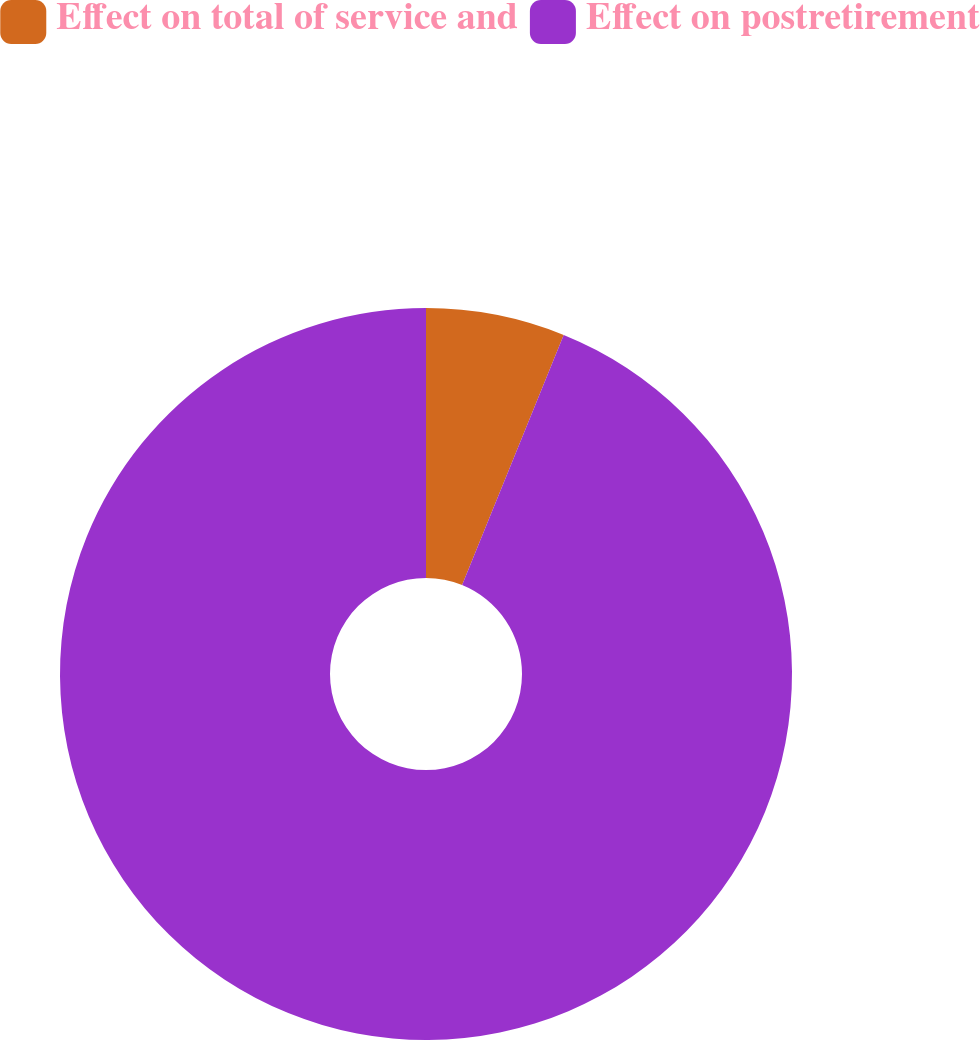<chart> <loc_0><loc_0><loc_500><loc_500><pie_chart><fcel>Effect on total of service and<fcel>Effect on postretirement<nl><fcel>6.14%<fcel>93.86%<nl></chart> 